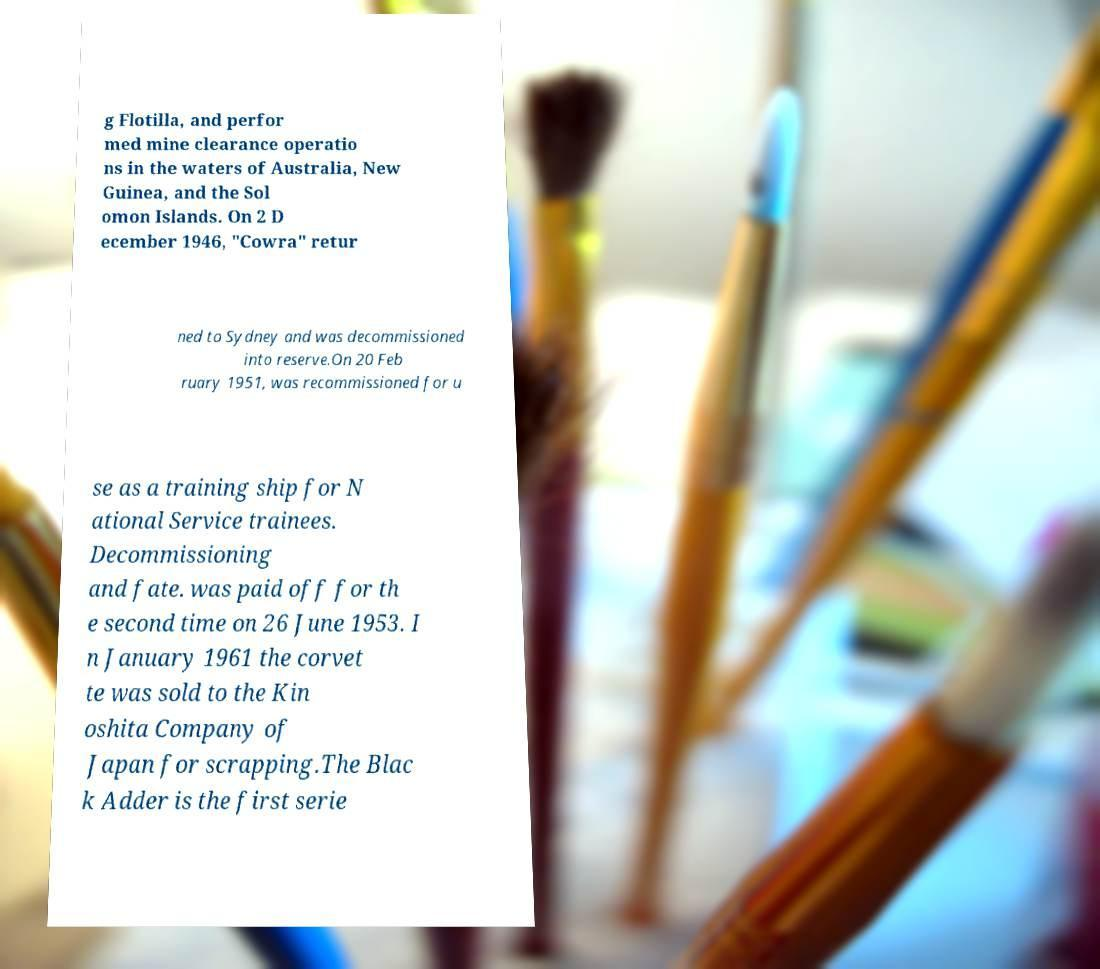There's text embedded in this image that I need extracted. Can you transcribe it verbatim? g Flotilla, and perfor med mine clearance operatio ns in the waters of Australia, New Guinea, and the Sol omon Islands. On 2 D ecember 1946, "Cowra" retur ned to Sydney and was decommissioned into reserve.On 20 Feb ruary 1951, was recommissioned for u se as a training ship for N ational Service trainees. Decommissioning and fate. was paid off for th e second time on 26 June 1953. I n January 1961 the corvet te was sold to the Kin oshita Company of Japan for scrapping.The Blac k Adder is the first serie 